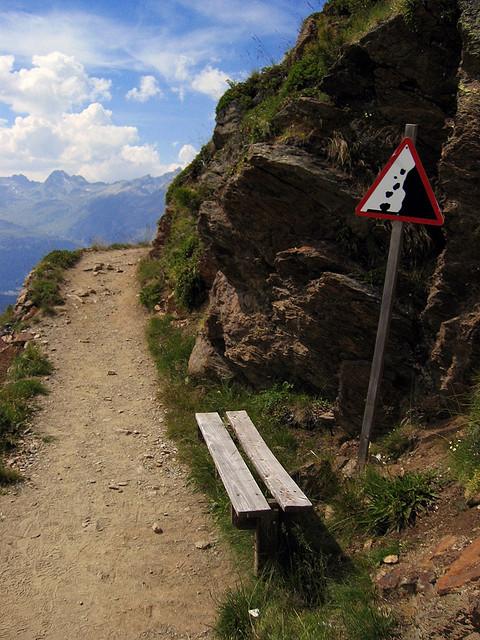Which way will the driver have to turn the wheel to follow the first curve?
Quick response, please. Right. Is there a signpost?
Be succinct. Yes. What is behind the signpost?
Short answer required. Rocks. Could this be called a tram?
Give a very brief answer. No. What is the bench made of?
Be succinct. Wood. 